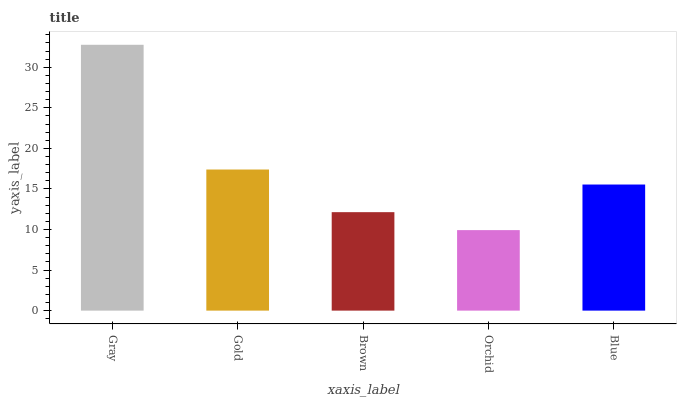Is Orchid the minimum?
Answer yes or no. Yes. Is Gray the maximum?
Answer yes or no. Yes. Is Gold the minimum?
Answer yes or no. No. Is Gold the maximum?
Answer yes or no. No. Is Gray greater than Gold?
Answer yes or no. Yes. Is Gold less than Gray?
Answer yes or no. Yes. Is Gold greater than Gray?
Answer yes or no. No. Is Gray less than Gold?
Answer yes or no. No. Is Blue the high median?
Answer yes or no. Yes. Is Blue the low median?
Answer yes or no. Yes. Is Gold the high median?
Answer yes or no. No. Is Orchid the low median?
Answer yes or no. No. 